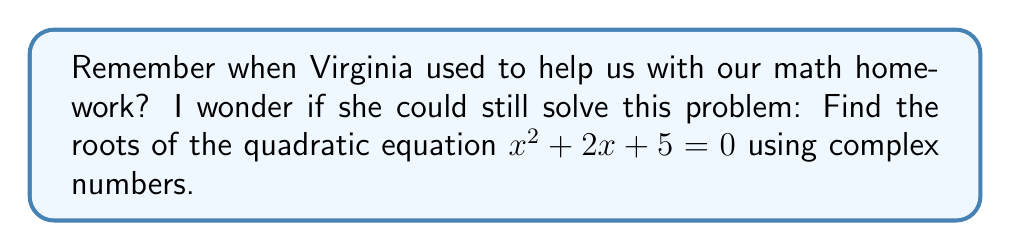Could you help me with this problem? To find the roots of the quadratic equation $x^2 + 2x + 5 = 0$, we'll use the quadratic formula:

$$x = \frac{-b \pm \sqrt{b^2 - 4ac}}{2a}$$

Where $a = 1$, $b = 2$, and $c = 5$.

1) First, let's calculate the discriminant $b^2 - 4ac$:
   $b^2 - 4ac = 2^2 - 4(1)(5) = 4 - 20 = -16$

2) Since the discriminant is negative, we know the roots will be complex.

3) Now, let's substitute into the quadratic formula:
   $$x = \frac{-2 \pm \sqrt{-16}}{2(1)}$$

4) Simplify $\sqrt{-16}$:
   $\sqrt{-16} = \sqrt{16} \cdot \sqrt{-1} = 4i$

5) Substitute back into the equation:
   $$x = \frac{-2 \pm 4i}{2}$$

6) Simplify:
   $$x = -1 \pm 2i$$

Therefore, the two roots are:
$x_1 = -1 + 2i$ and $x_2 = -1 - 2i$
Answer: $x_1 = -1 + 2i$, $x_2 = -1 - 2i$ 